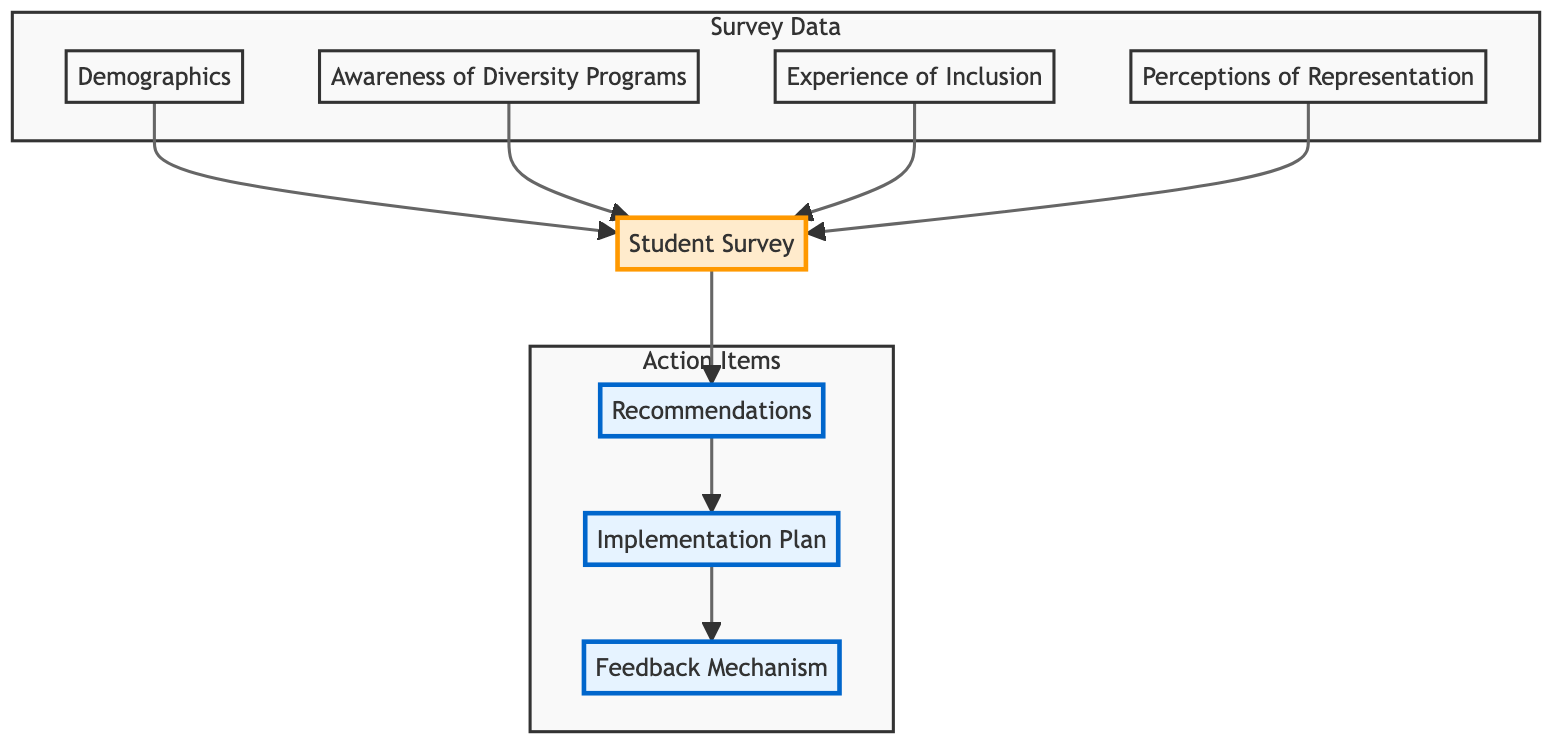What is the first element in the flow chart? The flow chart begins with the element "Student Survey." This can be determined by identifying the top node in the diagram.
Answer: Student Survey How many sub-elements are included in the "Survey Data" section? The "Survey Data" section contains four sub-elements: Demographics, Awareness of Diversity Programs, Experience of Inclusion, and Perceptions of Representation. These are counted individually in that portion of the diagram.
Answer: Four What action follows after "Recommendations"? The action that follows "Recommendations" in the flow chart is "Implementation Plan." This is identified by looking at the flow direction from the "Recommendations" node.
Answer: Implementation Plan Which two elements are directly connected to "Student Survey"? The two elements directly connected to "Student Survey" are "Demographics" and "Awareness of Diversity Programs." These connections are visually depicted as arrows leading from these elements to the "Student Survey."
Answer: Demographics and Awareness of Diversity Programs What is the purpose of the "Feedback Mechanism"? The "Feedback Mechanism" is designed to create channels for ongoing student feedback regarding diversity and inclusion efforts. This purpose is outlined in the description of that element in the diagram.
Answer: Ongoing student feedback Why do "Recommendations" lead to "Implementation Plan"? The "Recommendations" lead to "Implementation Plan" because the proposed actions based on survey feedback must be put into practice, which is specifically highlighted in the flow from one element to the other.
Answer: Proposed actions must be implemented What does the "Experience of Inclusion" element assess? The "Experience of Inclusion" element assesses feedback on how included students feel in school activities and discussions. This is directly stated in the description of that element within the diagram.
Answer: Inclusion in school activities What is the last step outlined in the flow chart? The last step outlined in the flow chart is "Feedback Mechanism." This can be seen as the final node in the progression of actions stemming from recommendations.
Answer: Feedback Mechanism 